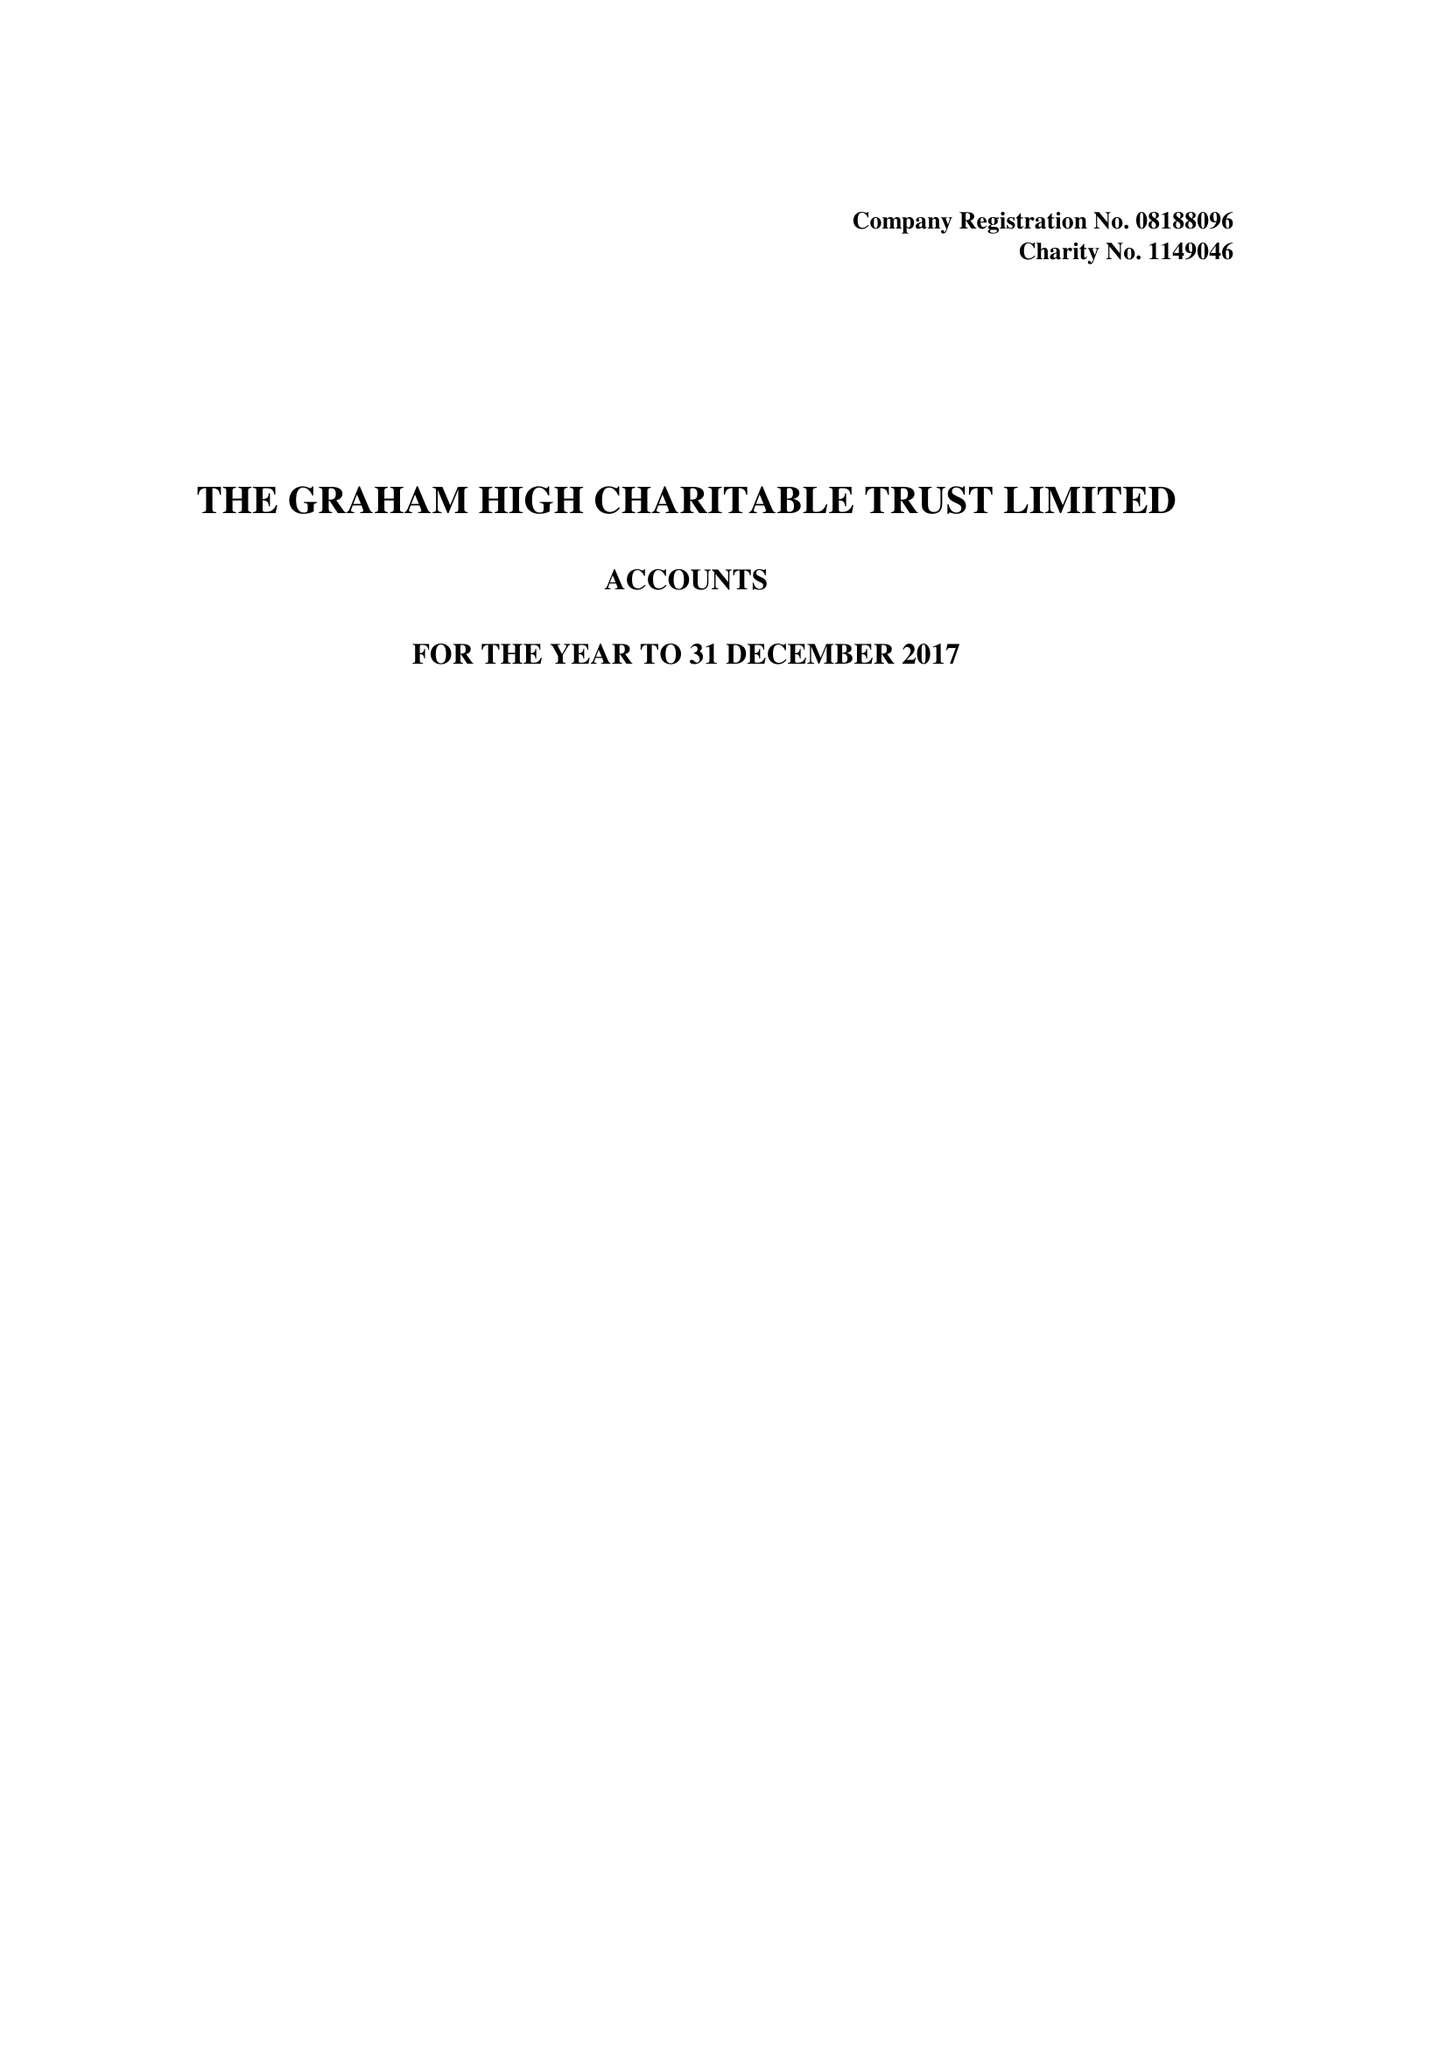What is the value for the address__post_town?
Answer the question using a single word or phrase. EASTLEIGH 